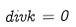<formula> <loc_0><loc_0><loc_500><loc_500>d i v k = 0</formula> 